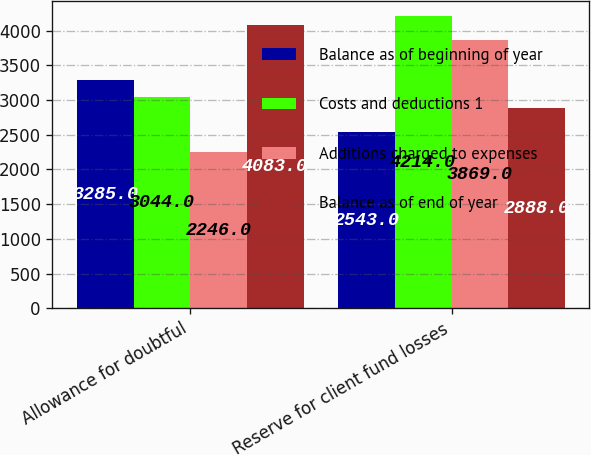<chart> <loc_0><loc_0><loc_500><loc_500><stacked_bar_chart><ecel><fcel>Allowance for doubtful<fcel>Reserve for client fund losses<nl><fcel>Balance as of beginning of year<fcel>3285<fcel>2543<nl><fcel>Costs and deductions 1<fcel>3044<fcel>4214<nl><fcel>Additions charged to expenses<fcel>2246<fcel>3869<nl><fcel>Balance as of end of year<fcel>4083<fcel>2888<nl></chart> 